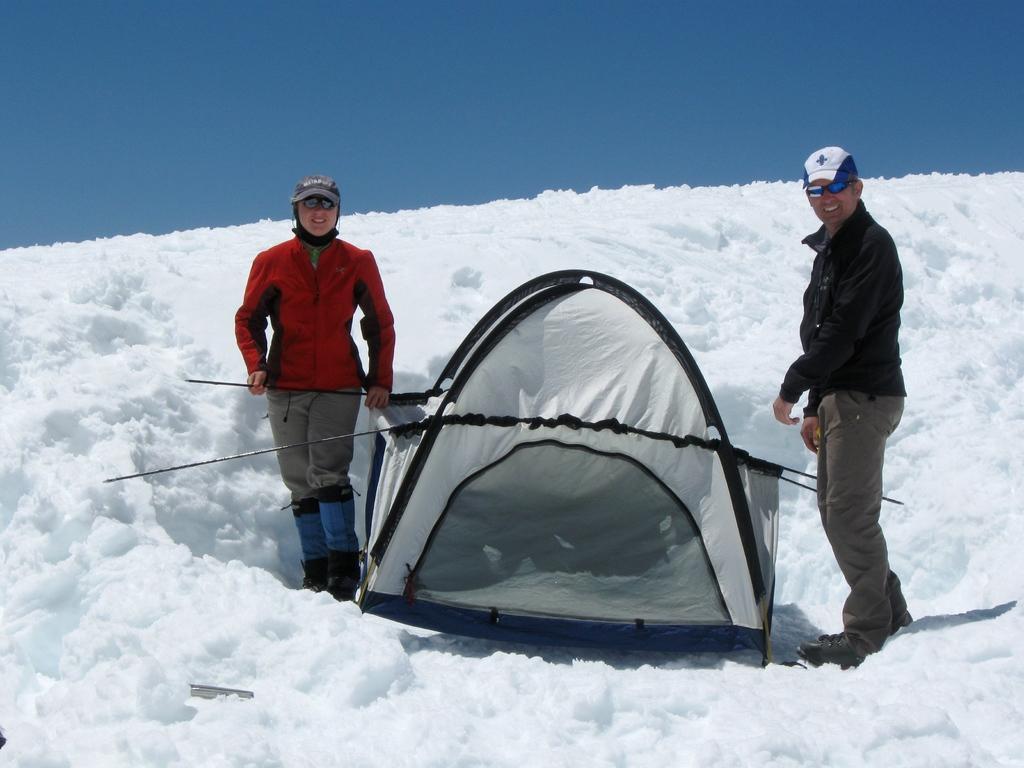Describe this image in one or two sentences. In this image I can see two persons are standing on the snow. Here I can see a tent. These people are wearing caps and shades. In the background I can see the sky. 